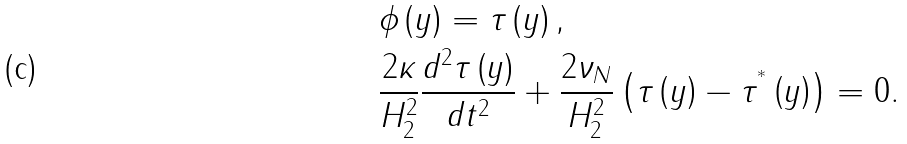<formula> <loc_0><loc_0><loc_500><loc_500>& \phi \left ( y \right ) = \tau \left ( y \right ) , \\ & \frac { 2 \kappa } { H _ { 2 } ^ { 2 } } \frac { d ^ { 2 } \tau \left ( y \right ) } { d t ^ { 2 } } + \frac { 2 \nu _ { N } } { H _ { 2 } ^ { 2 } } \left ( \tau \left ( y \right ) - \tau ^ { ^ { * } } \left ( y \right ) \right ) = 0 .</formula> 